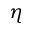Convert formula to latex. <formula><loc_0><loc_0><loc_500><loc_500>\eta</formula> 